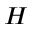Convert formula to latex. <formula><loc_0><loc_0><loc_500><loc_500>H</formula> 